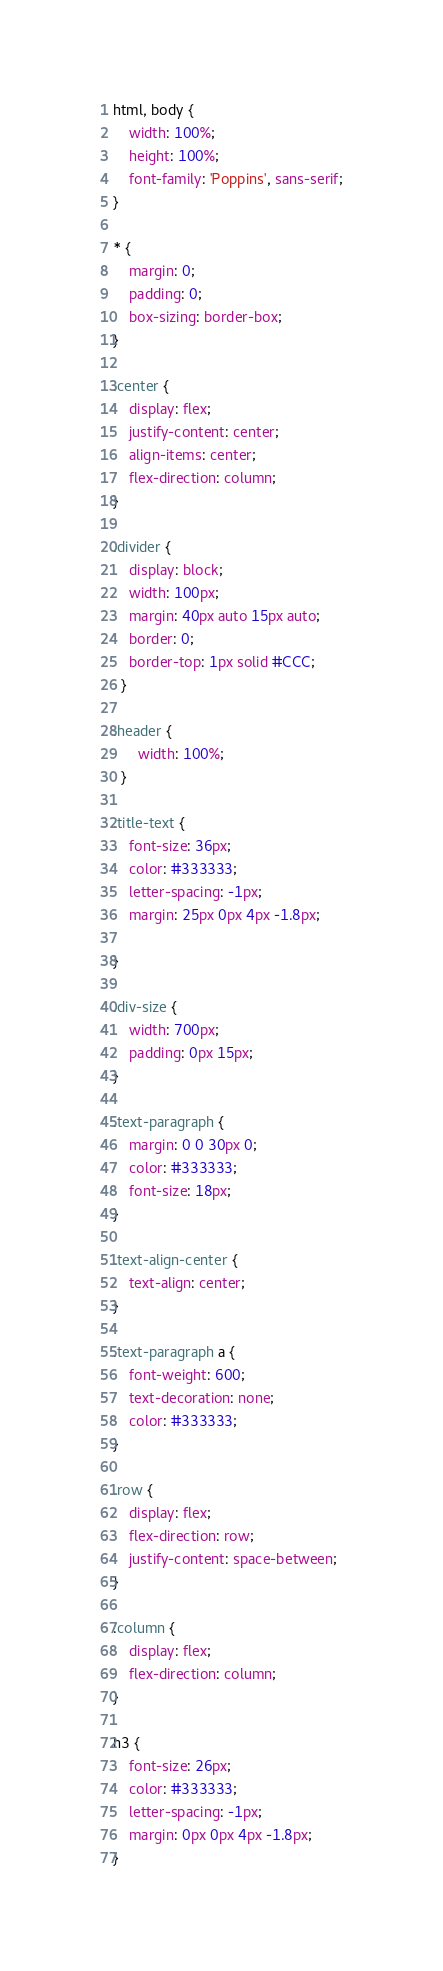<code> <loc_0><loc_0><loc_500><loc_500><_CSS_>html, body {
    width: 100%;
    height: 100%;
    font-family: 'Poppins', sans-serif;
}

* {
    margin: 0;
    padding: 0;
    box-sizing: border-box;
}

.center {
    display: flex;
    justify-content: center;
    align-items: center;
    flex-direction: column;
}

.divider {
    display: block;
    width: 100px;
    margin: 40px auto 15px auto;
    border: 0;
    border-top: 1px solid #CCC;
  }

.header {
      width: 100%;
  }
 
.title-text {
    font-size: 36px;
    color: #333333;
    letter-spacing: -1px;
    margin: 25px 0px 4px -1.8px;

}

.div-size {
    width: 700px;
    padding: 0px 15px;
}

.text-paragraph {
    margin: 0 0 30px 0;
    color: #333333;
    font-size: 18px;
}

.text-align-center {
    text-align: center;
}

.text-paragraph a {
    font-weight: 600;
    text-decoration: none;
    color: #333333;
}

.row {
    display: flex;
    flex-direction: row;
    justify-content: space-between;
}

.column {
    display: flex;
    flex-direction: column;
}

h3 {
    font-size: 26px;
    color: #333333;
    letter-spacing: -1px;
    margin: 0px 0px 4px -1.8px;
}</code> 